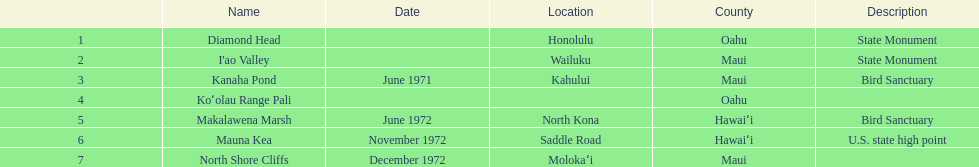What's the count of images mentioned in the list? 6. 